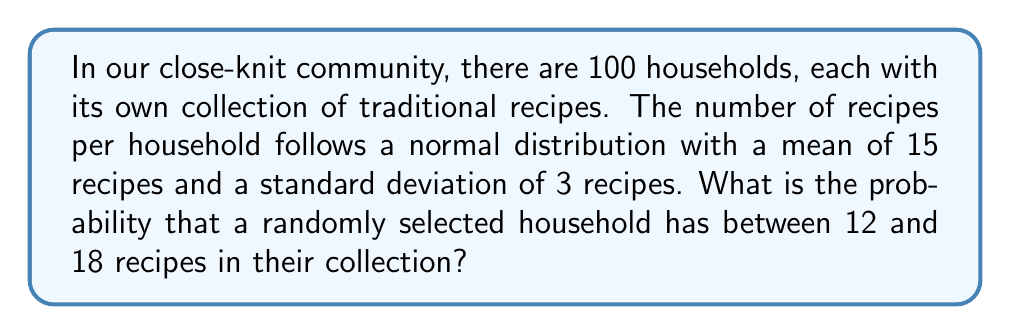What is the answer to this math problem? Let's approach this step-by-step:

1) Let $X$ be the random variable representing the number of recipes in a household. We're given that $X$ follows a normal distribution with:
   
   $\mu = 15$ (mean)
   $\sigma = 3$ (standard deviation)

2) We want to find $P(12 \leq X \leq 18)$

3) To solve this, we need to standardize these values to z-scores:

   For $X = 12$: $z_1 = \frac{12 - 15}{3} = -1$
   For $X = 18$: $z_2 = \frac{18 - 15}{3} = 1$

4) Now, we're looking for $P(-1 \leq Z \leq 1)$, where $Z$ is the standard normal variable.

5) Using the standard normal distribution table or a calculator:

   $P(Z \leq 1) = 0.8413$
   $P(Z \leq -1) = 0.1587$

6) Therefore:

   $P(-1 \leq Z \leq 1) = P(Z \leq 1) - P(Z \leq -1)$
                         $= 0.8413 - 0.1587$
                         $= 0.6826$

7) This means there's a 68.26% chance that a randomly selected household has between 12 and 18 recipes.
Answer: 0.6826 or 68.26% 